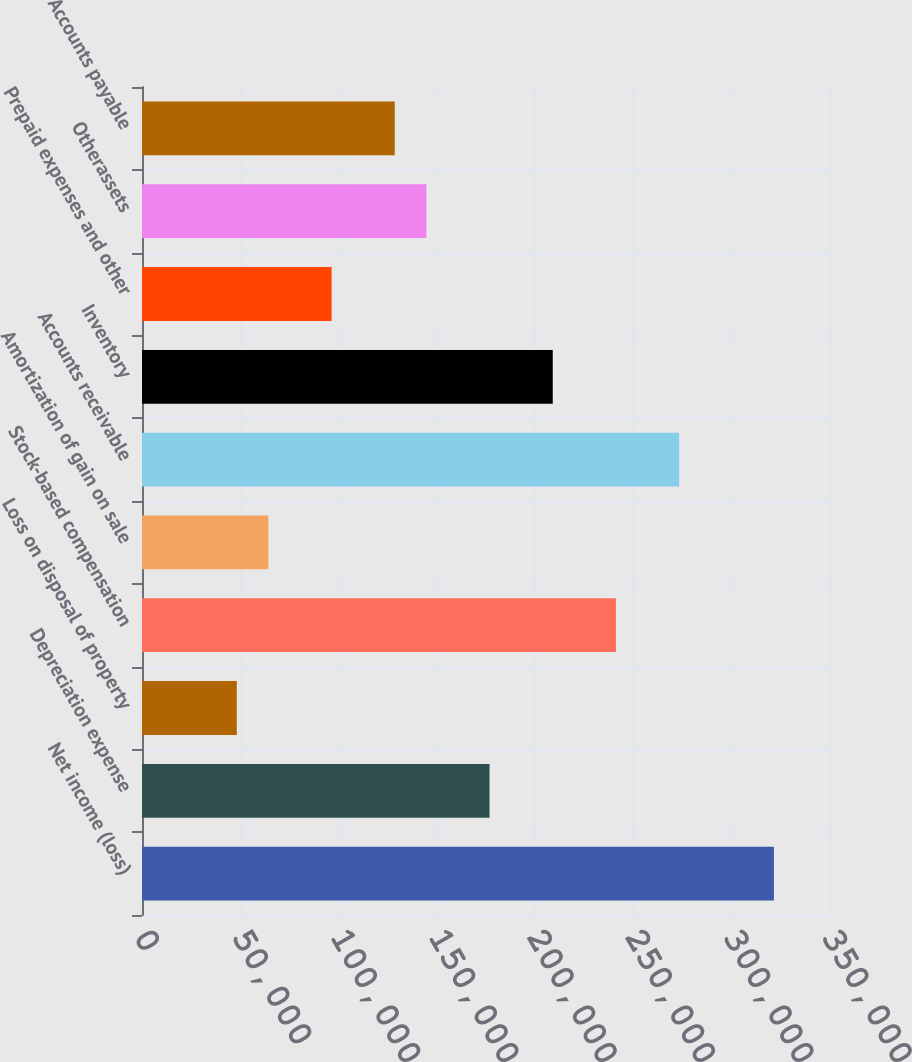<chart> <loc_0><loc_0><loc_500><loc_500><bar_chart><fcel>Net income (loss)<fcel>Depreciation expense<fcel>Loss on disposal of property<fcel>Stock-based compensation<fcel>Amortization of gain on sale<fcel>Accounts receivable<fcel>Inventory<fcel>Prepaid expenses and other<fcel>Otherassets<fcel>Accounts payable<nl><fcel>321467<fcel>176808<fcel>48222.6<fcel>241101<fcel>64295.8<fcel>273247<fcel>208955<fcel>96442.2<fcel>144662<fcel>128589<nl></chart> 